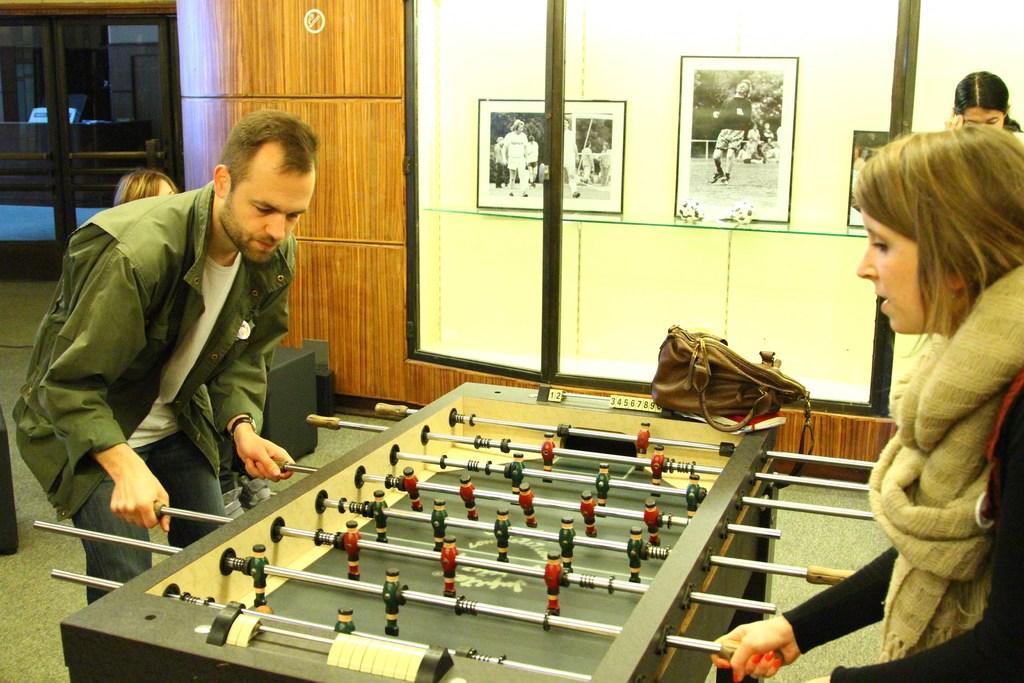Please provide a concise description of this image. There is a man and woman playing game on the table behind her there is a woman standing and so many photo frames on the wall. 